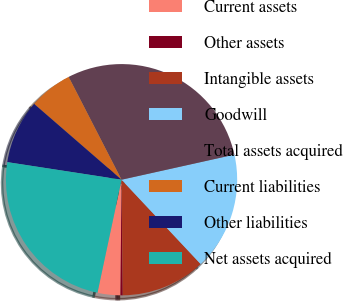Convert chart. <chart><loc_0><loc_0><loc_500><loc_500><pie_chart><fcel>Current assets<fcel>Other assets<fcel>Intangible assets<fcel>Goodwill<fcel>Total assets acquired<fcel>Current liabilities<fcel>Other liabilities<fcel>Net assets acquired<nl><fcel>3.19%<fcel>0.32%<fcel>11.82%<fcel>16.49%<fcel>29.08%<fcel>6.07%<fcel>8.94%<fcel>24.09%<nl></chart> 